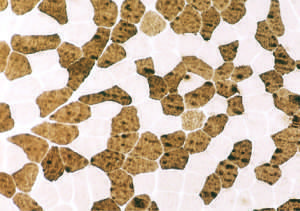what is corresponding to findings in the fig.711?
Answer the question using a single word or phrase. Normal muscle has a checkerboard distribution of type i and type ii fibers 